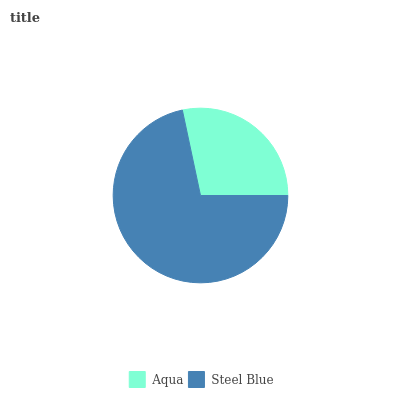Is Aqua the minimum?
Answer yes or no. Yes. Is Steel Blue the maximum?
Answer yes or no. Yes. Is Steel Blue the minimum?
Answer yes or no. No. Is Steel Blue greater than Aqua?
Answer yes or no. Yes. Is Aqua less than Steel Blue?
Answer yes or no. Yes. Is Aqua greater than Steel Blue?
Answer yes or no. No. Is Steel Blue less than Aqua?
Answer yes or no. No. Is Steel Blue the high median?
Answer yes or no. Yes. Is Aqua the low median?
Answer yes or no. Yes. Is Aqua the high median?
Answer yes or no. No. Is Steel Blue the low median?
Answer yes or no. No. 